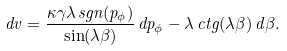<formula> <loc_0><loc_0><loc_500><loc_500>d v = \frac { \kappa \gamma \lambda \, s g n ( p _ { \phi } ) } { \sin ( \lambda \beta ) } \, d p _ { \phi } - \lambda \, c t g ( \lambda \beta ) \, d \beta .</formula> 